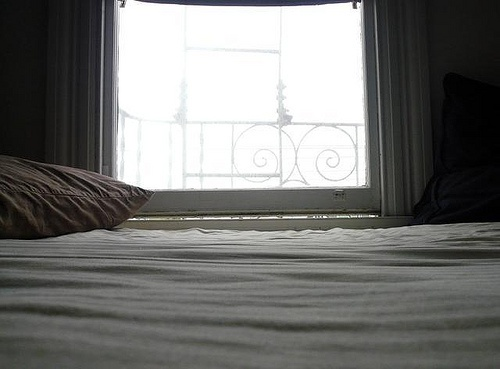Describe the objects in this image and their specific colors. I can see a bed in black, gray, and darkgray tones in this image. 